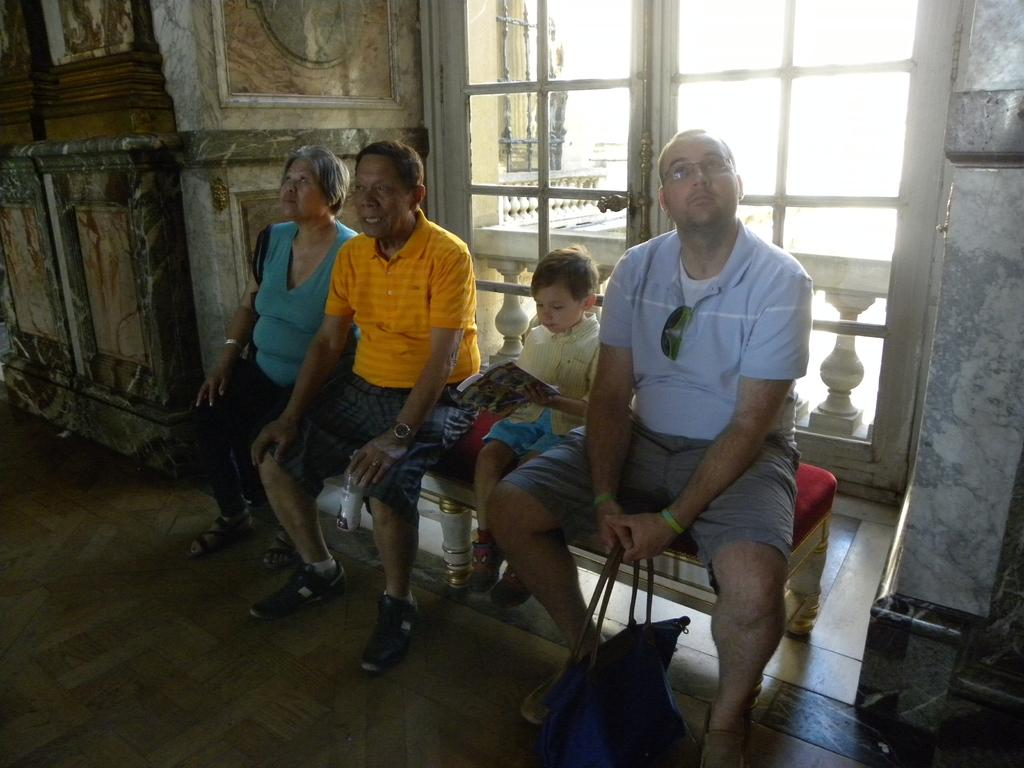How many people are in the image? There is a group of people in the image. What are the people doing in the image? The people are sitting on a bench. Can you describe what the man is holding in the image? A man is holding a bag. What is the child holding in the image? The child is holding a book. What architectural feature can be seen in the image? There is railing visible in the image. What can be seen through the window in the image? There is a wall visible through the window in the image. What sense is being stimulated by the wall in the image? There is no indication in the image that any sense is being stimulated by the wall. 